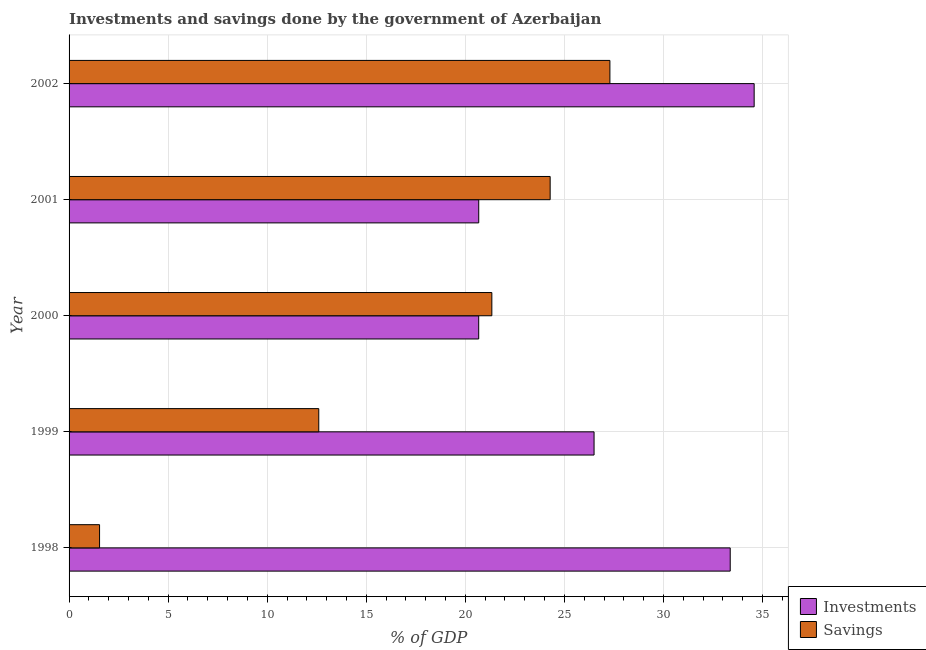Are the number of bars per tick equal to the number of legend labels?
Keep it short and to the point. Yes. How many bars are there on the 5th tick from the top?
Offer a very short reply. 2. What is the label of the 1st group of bars from the top?
Give a very brief answer. 2002. In how many cases, is the number of bars for a given year not equal to the number of legend labels?
Ensure brevity in your answer.  0. What is the savings of government in 2001?
Make the answer very short. 24.28. Across all years, what is the maximum savings of government?
Your answer should be compact. 27.3. Across all years, what is the minimum savings of government?
Offer a very short reply. 1.54. In which year was the investments of government maximum?
Give a very brief answer. 2002. In which year was the savings of government minimum?
Offer a terse response. 1998. What is the total savings of government in the graph?
Provide a short and direct response. 87.05. What is the difference between the investments of government in 1998 and that in 2000?
Your response must be concise. 12.69. What is the difference between the savings of government in 1998 and the investments of government in 2001?
Give a very brief answer. -19.14. What is the average investments of government per year?
Provide a short and direct response. 27.16. In the year 2001, what is the difference between the investments of government and savings of government?
Provide a short and direct response. -3.6. In how many years, is the savings of government greater than 25 %?
Provide a succinct answer. 1. What is the ratio of the savings of government in 1999 to that in 2002?
Offer a terse response. 0.46. Is the investments of government in 1998 less than that in 2001?
Keep it short and to the point. No. Is the difference between the savings of government in 1998 and 2001 greater than the difference between the investments of government in 1998 and 2001?
Ensure brevity in your answer.  No. What is the difference between the highest and the second highest investments of government?
Provide a succinct answer. 1.21. What is the difference between the highest and the lowest investments of government?
Offer a very short reply. 13.9. In how many years, is the savings of government greater than the average savings of government taken over all years?
Offer a terse response. 3. What does the 2nd bar from the top in 1998 represents?
Your answer should be compact. Investments. What does the 1st bar from the bottom in 2001 represents?
Keep it short and to the point. Investments. How many bars are there?
Your response must be concise. 10. Are all the bars in the graph horizontal?
Give a very brief answer. Yes. How many years are there in the graph?
Your answer should be very brief. 5. Are the values on the major ticks of X-axis written in scientific E-notation?
Ensure brevity in your answer.  No. Does the graph contain any zero values?
Ensure brevity in your answer.  No. Does the graph contain grids?
Offer a very short reply. Yes. How many legend labels are there?
Provide a succinct answer. 2. What is the title of the graph?
Provide a short and direct response. Investments and savings done by the government of Azerbaijan. What is the label or title of the X-axis?
Your response must be concise. % of GDP. What is the label or title of the Y-axis?
Provide a succinct answer. Year. What is the % of GDP in Investments in 1998?
Ensure brevity in your answer.  33.37. What is the % of GDP in Savings in 1998?
Provide a succinct answer. 1.54. What is the % of GDP of Investments in 1999?
Provide a short and direct response. 26.5. What is the % of GDP in Savings in 1999?
Offer a terse response. 12.6. What is the % of GDP in Investments in 2000?
Your answer should be compact. 20.67. What is the % of GDP of Savings in 2000?
Provide a short and direct response. 21.34. What is the % of GDP in Investments in 2001?
Offer a terse response. 20.68. What is the % of GDP of Savings in 2001?
Ensure brevity in your answer.  24.28. What is the % of GDP in Investments in 2002?
Your answer should be very brief. 34.58. What is the % of GDP in Savings in 2002?
Give a very brief answer. 27.3. Across all years, what is the maximum % of GDP in Investments?
Ensure brevity in your answer.  34.58. Across all years, what is the maximum % of GDP of Savings?
Make the answer very short. 27.3. Across all years, what is the minimum % of GDP of Investments?
Offer a terse response. 20.67. Across all years, what is the minimum % of GDP of Savings?
Give a very brief answer. 1.54. What is the total % of GDP in Investments in the graph?
Ensure brevity in your answer.  135.79. What is the total % of GDP of Savings in the graph?
Provide a succinct answer. 87.05. What is the difference between the % of GDP in Investments in 1998 and that in 1999?
Give a very brief answer. 6.87. What is the difference between the % of GDP of Savings in 1998 and that in 1999?
Provide a succinct answer. -11.06. What is the difference between the % of GDP of Investments in 1998 and that in 2000?
Ensure brevity in your answer.  12.69. What is the difference between the % of GDP in Savings in 1998 and that in 2000?
Give a very brief answer. -19.8. What is the difference between the % of GDP of Investments in 1998 and that in 2001?
Your answer should be compact. 12.69. What is the difference between the % of GDP in Savings in 1998 and that in 2001?
Ensure brevity in your answer.  -22.74. What is the difference between the % of GDP of Investments in 1998 and that in 2002?
Offer a terse response. -1.21. What is the difference between the % of GDP of Savings in 1998 and that in 2002?
Make the answer very short. -25.76. What is the difference between the % of GDP of Investments in 1999 and that in 2000?
Provide a short and direct response. 5.82. What is the difference between the % of GDP in Savings in 1999 and that in 2000?
Your answer should be very brief. -8.74. What is the difference between the % of GDP in Investments in 1999 and that in 2001?
Offer a very short reply. 5.82. What is the difference between the % of GDP in Savings in 1999 and that in 2001?
Your answer should be very brief. -11.68. What is the difference between the % of GDP in Investments in 1999 and that in 2002?
Offer a terse response. -8.08. What is the difference between the % of GDP of Savings in 1999 and that in 2002?
Make the answer very short. -14.69. What is the difference between the % of GDP of Investments in 2000 and that in 2001?
Offer a terse response. -0. What is the difference between the % of GDP in Savings in 2000 and that in 2001?
Keep it short and to the point. -2.94. What is the difference between the % of GDP in Investments in 2000 and that in 2002?
Keep it short and to the point. -13.9. What is the difference between the % of GDP of Savings in 2000 and that in 2002?
Your answer should be compact. -5.96. What is the difference between the % of GDP of Investments in 2001 and that in 2002?
Your response must be concise. -13.9. What is the difference between the % of GDP in Savings in 2001 and that in 2002?
Offer a very short reply. -3.02. What is the difference between the % of GDP of Investments in 1998 and the % of GDP of Savings in 1999?
Provide a short and direct response. 20.77. What is the difference between the % of GDP in Investments in 1998 and the % of GDP in Savings in 2000?
Make the answer very short. 12.03. What is the difference between the % of GDP in Investments in 1998 and the % of GDP in Savings in 2001?
Offer a very short reply. 9.09. What is the difference between the % of GDP of Investments in 1998 and the % of GDP of Savings in 2002?
Offer a terse response. 6.07. What is the difference between the % of GDP of Investments in 1999 and the % of GDP of Savings in 2000?
Offer a very short reply. 5.16. What is the difference between the % of GDP of Investments in 1999 and the % of GDP of Savings in 2001?
Ensure brevity in your answer.  2.22. What is the difference between the % of GDP in Investments in 1999 and the % of GDP in Savings in 2002?
Provide a short and direct response. -0.8. What is the difference between the % of GDP of Investments in 2000 and the % of GDP of Savings in 2001?
Give a very brief answer. -3.61. What is the difference between the % of GDP of Investments in 2000 and the % of GDP of Savings in 2002?
Offer a terse response. -6.62. What is the difference between the % of GDP in Investments in 2001 and the % of GDP in Savings in 2002?
Offer a terse response. -6.62. What is the average % of GDP of Investments per year?
Keep it short and to the point. 27.16. What is the average % of GDP of Savings per year?
Your answer should be very brief. 17.41. In the year 1998, what is the difference between the % of GDP of Investments and % of GDP of Savings?
Provide a short and direct response. 31.83. In the year 1999, what is the difference between the % of GDP in Investments and % of GDP in Savings?
Your answer should be compact. 13.89. In the year 2000, what is the difference between the % of GDP of Investments and % of GDP of Savings?
Ensure brevity in your answer.  -0.66. In the year 2001, what is the difference between the % of GDP in Investments and % of GDP in Savings?
Provide a short and direct response. -3.61. In the year 2002, what is the difference between the % of GDP in Investments and % of GDP in Savings?
Keep it short and to the point. 7.28. What is the ratio of the % of GDP of Investments in 1998 to that in 1999?
Ensure brevity in your answer.  1.26. What is the ratio of the % of GDP of Savings in 1998 to that in 1999?
Your response must be concise. 0.12. What is the ratio of the % of GDP of Investments in 1998 to that in 2000?
Make the answer very short. 1.61. What is the ratio of the % of GDP in Savings in 1998 to that in 2000?
Offer a terse response. 0.07. What is the ratio of the % of GDP in Investments in 1998 to that in 2001?
Your answer should be compact. 1.61. What is the ratio of the % of GDP in Savings in 1998 to that in 2001?
Keep it short and to the point. 0.06. What is the ratio of the % of GDP of Investments in 1998 to that in 2002?
Make the answer very short. 0.97. What is the ratio of the % of GDP in Savings in 1998 to that in 2002?
Provide a short and direct response. 0.06. What is the ratio of the % of GDP in Investments in 1999 to that in 2000?
Ensure brevity in your answer.  1.28. What is the ratio of the % of GDP of Savings in 1999 to that in 2000?
Ensure brevity in your answer.  0.59. What is the ratio of the % of GDP of Investments in 1999 to that in 2001?
Offer a very short reply. 1.28. What is the ratio of the % of GDP in Savings in 1999 to that in 2001?
Give a very brief answer. 0.52. What is the ratio of the % of GDP in Investments in 1999 to that in 2002?
Make the answer very short. 0.77. What is the ratio of the % of GDP in Savings in 1999 to that in 2002?
Keep it short and to the point. 0.46. What is the ratio of the % of GDP of Savings in 2000 to that in 2001?
Your response must be concise. 0.88. What is the ratio of the % of GDP of Investments in 2000 to that in 2002?
Provide a succinct answer. 0.6. What is the ratio of the % of GDP of Savings in 2000 to that in 2002?
Your response must be concise. 0.78. What is the ratio of the % of GDP of Investments in 2001 to that in 2002?
Give a very brief answer. 0.6. What is the ratio of the % of GDP in Savings in 2001 to that in 2002?
Keep it short and to the point. 0.89. What is the difference between the highest and the second highest % of GDP in Investments?
Keep it short and to the point. 1.21. What is the difference between the highest and the second highest % of GDP of Savings?
Your response must be concise. 3.02. What is the difference between the highest and the lowest % of GDP of Investments?
Ensure brevity in your answer.  13.9. What is the difference between the highest and the lowest % of GDP of Savings?
Ensure brevity in your answer.  25.76. 